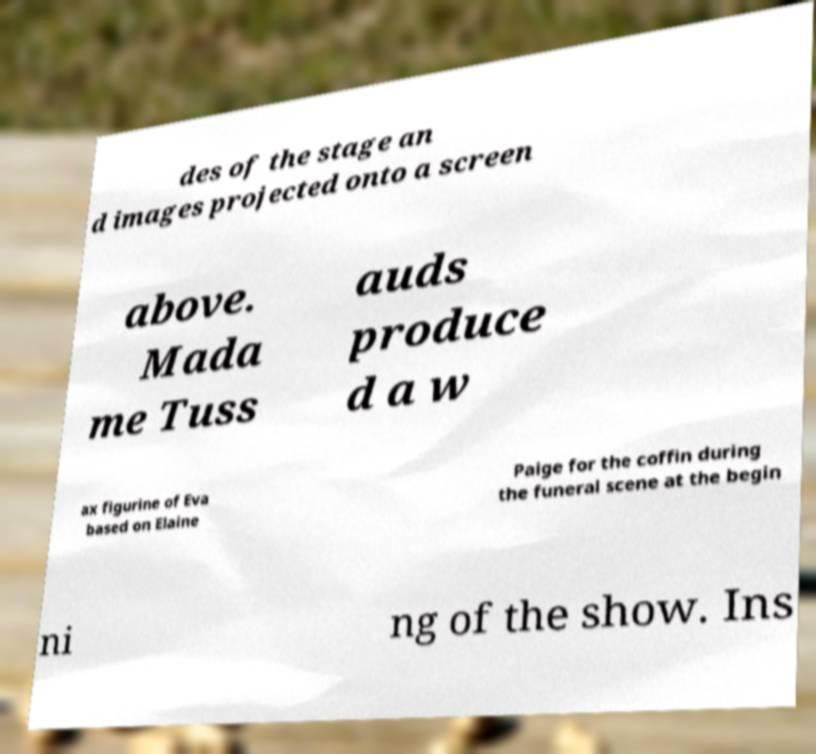There's text embedded in this image that I need extracted. Can you transcribe it verbatim? des of the stage an d images projected onto a screen above. Mada me Tuss auds produce d a w ax figurine of Eva based on Elaine Paige for the coffin during the funeral scene at the begin ni ng of the show. Ins 